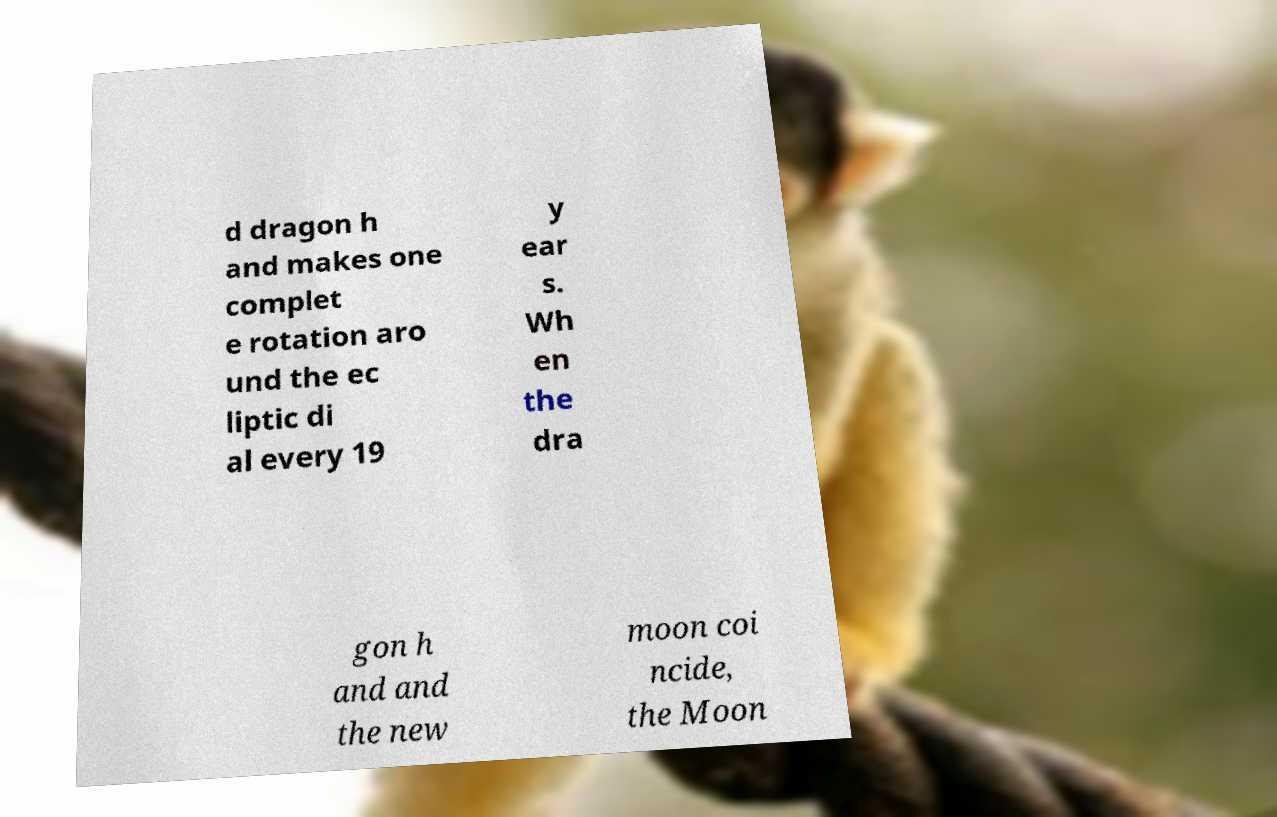What messages or text are displayed in this image? I need them in a readable, typed format. d dragon h and makes one complet e rotation aro und the ec liptic di al every 19 y ear s. Wh en the dra gon h and and the new moon coi ncide, the Moon 